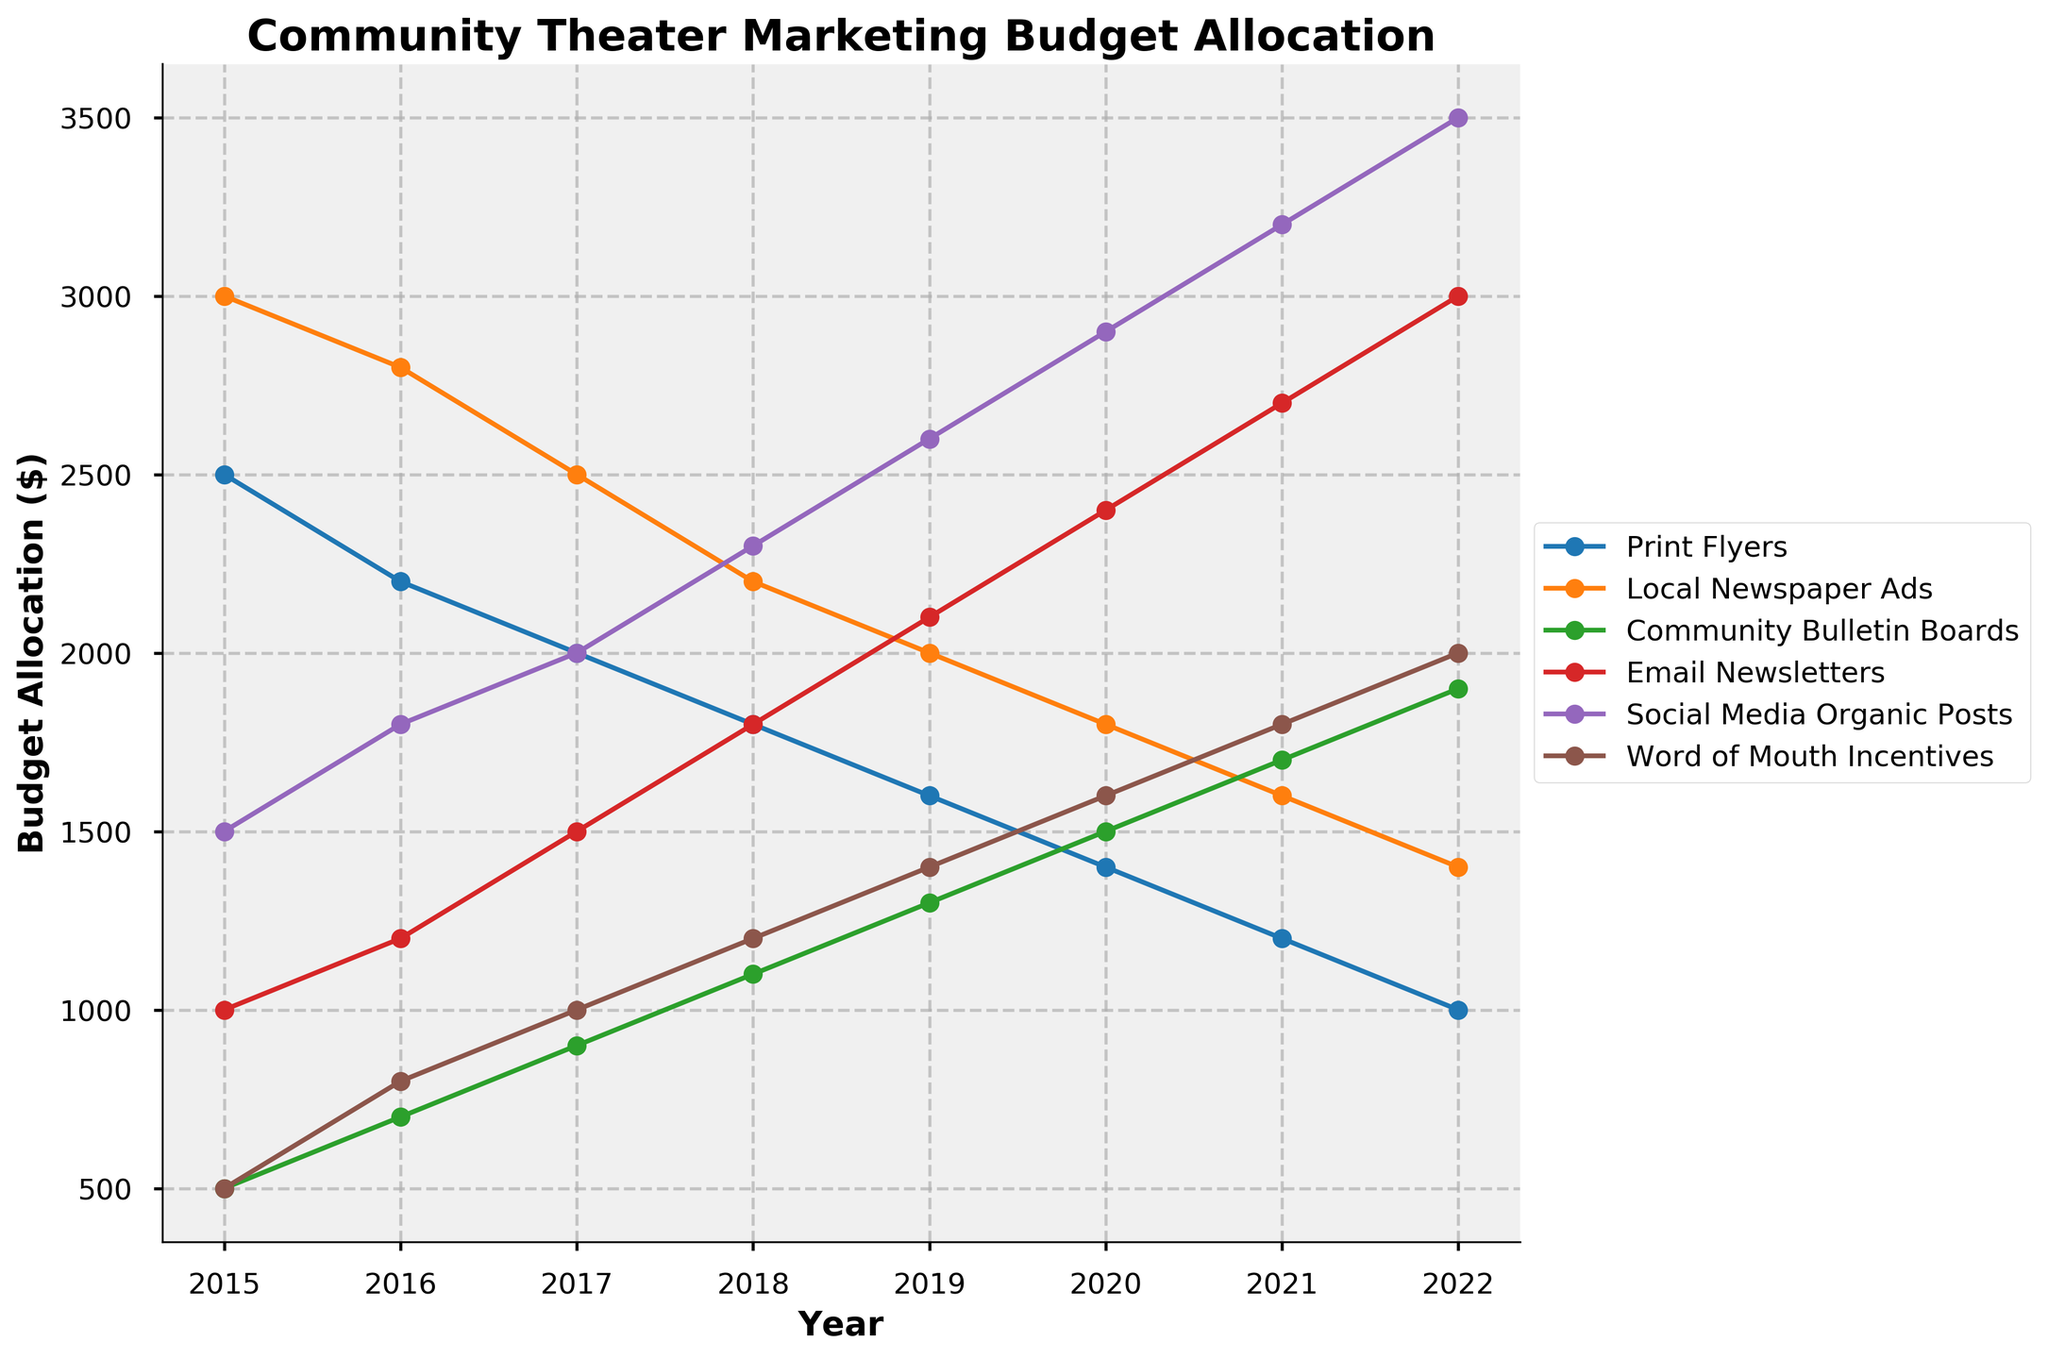Which marketing strategy showed the highest budget allocation in 2022? First, look at the endpoint of the line for each marketing strategy in 2022. The highest budget allocation in 2022 corresponds to the line that reaches the highest point on the y-axis. For 2022, "Social Media Organic Posts" has the highest value.
Answer: Social Media Organic Posts How did the budget allocation for Print Flyers change from 2015 to 2022? Find the values for Print Flyers in 2015 and 2022. In 2015, it was $2500, and in 2022, it decreased to $1000.
Answer: Decreased by $1500 Which marketing strategy had the most consistent increase in budget allocation over the years? Observe the slope of each line. The strategy with the most consistent increase will have a steady upward trend without sharp dips or variations. "Social Media Organic Posts" shows a consistent steady increase every year.
Answer: Social Media Organic Posts Between 2018 and 2020, which strategy saw the greatest absolute increase in budget allocation? Calculate the difference in budget allocation between 2018 and 2020 for each strategy. The differences are: Print Flyers (-$400), Local Newspaper Ads (-$200), Community Bulletin Boards (+$400), Email Newsletters (+$600), Social Media Organic Posts (+$600), Word of Mouth Incentives (+$400). So, "Email Newsletters" and "Social Media Organic Posts" both saw the greatest increase of $600.
Answer: Email Newsletters and Social Media Organic Posts What is the total budget allocation for Word of Mouth Incentives from 2015 to 2022? Sum up the values for Word of Mouth Incentives from each year. The values are 500, 800, 1000, 1200, 1400, 1600, 1800, 2000. The total is 500 + 800 + 1000 + 1200 + 1400 + 1600 + 1800 + 2000 = 10300.
Answer: $10300 Which year did Local Newspaper Ads show the lowest budget allocation, and what was the amount? Look at each year and find the minimum value for Local Newspaper Ads. In 2022, the budget is $1400, which is the lowest.
Answer: 2022, $1400 Compare the budget allocation for Email Newsletters and Print Flyers in 2020. Which one was higher and by how much? In 2020, the budget for Email Newsletters was $2400, and for Print Flyers, it was $1400. Calculate the difference: 2400 - 1400 = 1000. Thus, Email Newsletters had a higher budget by $1000.
Answer: Email Newsletters by $1000 In which year did Community Bulletin Boards' budget allocation surpass that of Local Newspaper Ads for the first time? Track the budget allocations over the years and compare them yearly. In 2017, Community Bulletin Boards had $900 while Local Newspaper Ads had $2500, but in 2020, Community Bulletin Boards had $1500 and Local Newspaper Ads had $1800. The first year Community Bulletin Boards surpasses Local Newspaper Ads is 2021.
Answer: 2021 What’s the average budget allocation for Social Media Organic Posts across all years? Add up the yearly budgets for Social Media Organic Posts and divide by the number of years. The sum is 1500 + 1800 + 2000 + 2300 + 2600 + 2900 + 3200 + 3500 = 19800. There are 8 years, so 19800 / 8 = 2475.
Answer: $2475 